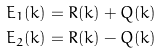<formula> <loc_0><loc_0><loc_500><loc_500>& E _ { 1 } ( { k } ) = R ( { k } ) + Q ( { k } ) \\ & E _ { 2 } ( { k } ) = R ( { k } ) - Q ( { k } )</formula> 